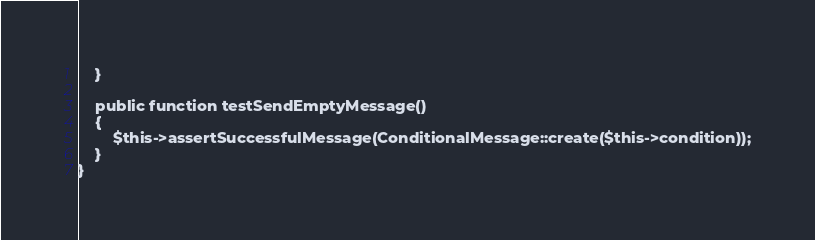<code> <loc_0><loc_0><loc_500><loc_500><_PHP_>    }

    public function testSendEmptyMessage()
    {
        $this->assertSuccessfulMessage(ConditionalMessage::create($this->condition));
    }
}
</code> 